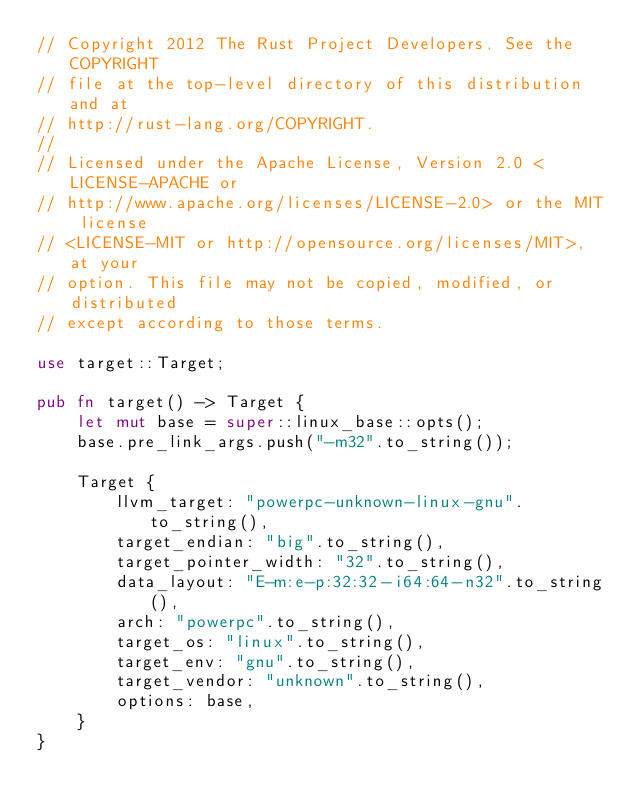<code> <loc_0><loc_0><loc_500><loc_500><_Rust_>// Copyright 2012 The Rust Project Developers. See the COPYRIGHT
// file at the top-level directory of this distribution and at
// http://rust-lang.org/COPYRIGHT.
//
// Licensed under the Apache License, Version 2.0 <LICENSE-APACHE or
// http://www.apache.org/licenses/LICENSE-2.0> or the MIT license
// <LICENSE-MIT or http://opensource.org/licenses/MIT>, at your
// option. This file may not be copied, modified, or distributed
// except according to those terms.

use target::Target;

pub fn target() -> Target {
    let mut base = super::linux_base::opts();
    base.pre_link_args.push("-m32".to_string());

    Target {
        llvm_target: "powerpc-unknown-linux-gnu".to_string(),
        target_endian: "big".to_string(),
        target_pointer_width: "32".to_string(),
        data_layout: "E-m:e-p:32:32-i64:64-n32".to_string(),
        arch: "powerpc".to_string(),
        target_os: "linux".to_string(),
        target_env: "gnu".to_string(),
        target_vendor: "unknown".to_string(),
        options: base,
    }
}
</code> 